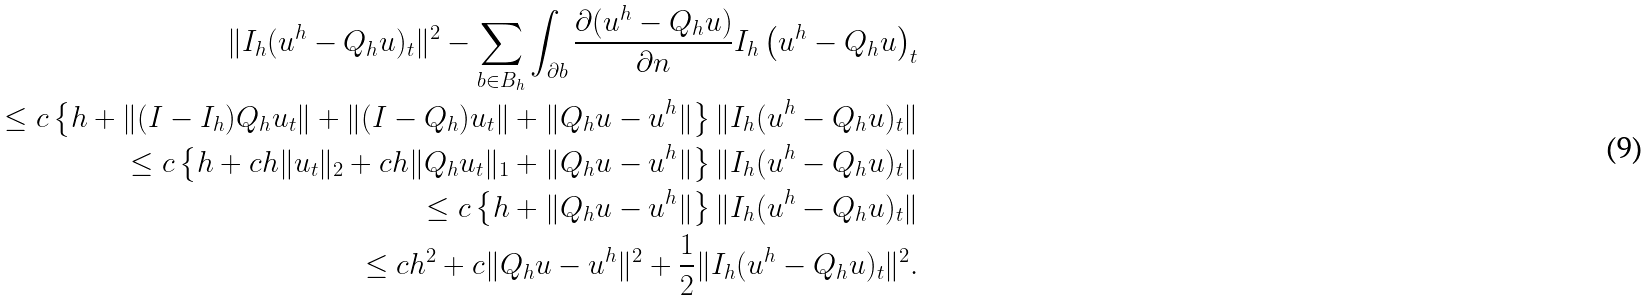<formula> <loc_0><loc_0><loc_500><loc_500>\| I _ { h } ( u ^ { h } - Q _ { h } u ) _ { t } \| ^ { 2 } - \sum _ { b \in B _ { h } } \int _ { \partial b } \frac { \partial ( u ^ { h } - Q _ { h } u ) } { \partial n } I _ { h } \left ( u ^ { h } - Q _ { h } u \right ) _ { t } \\ \leq c \left \{ h + \| ( I - I _ { h } ) Q _ { h } u _ { t } \| + \| ( I - Q _ { h } ) u _ { t } \| + \| Q _ { h } u - u ^ { h } \| \right \} \| I _ { h } ( u ^ { h } - Q _ { h } u ) _ { t } \| \\ \leq c \left \{ h + c h \| u _ { t } \| _ { 2 } + c h \| Q _ { h } u _ { t } \| _ { 1 } + \| Q _ { h } u - u ^ { h } \| \right \} \| I _ { h } ( u ^ { h } - Q _ { h } u ) _ { t } \| \\ \leq c \left \{ h + \| Q _ { h } u - u ^ { h } \| \right \} \| I _ { h } ( u ^ { h } - Q _ { h } u ) _ { t } \| \\ \leq c h ^ { 2 } + c \| Q _ { h } u - u ^ { h } \| ^ { 2 } + \frac { 1 } { 2 } \| I _ { h } ( u ^ { h } - Q _ { h } u ) _ { t } \| ^ { 2 } .</formula> 